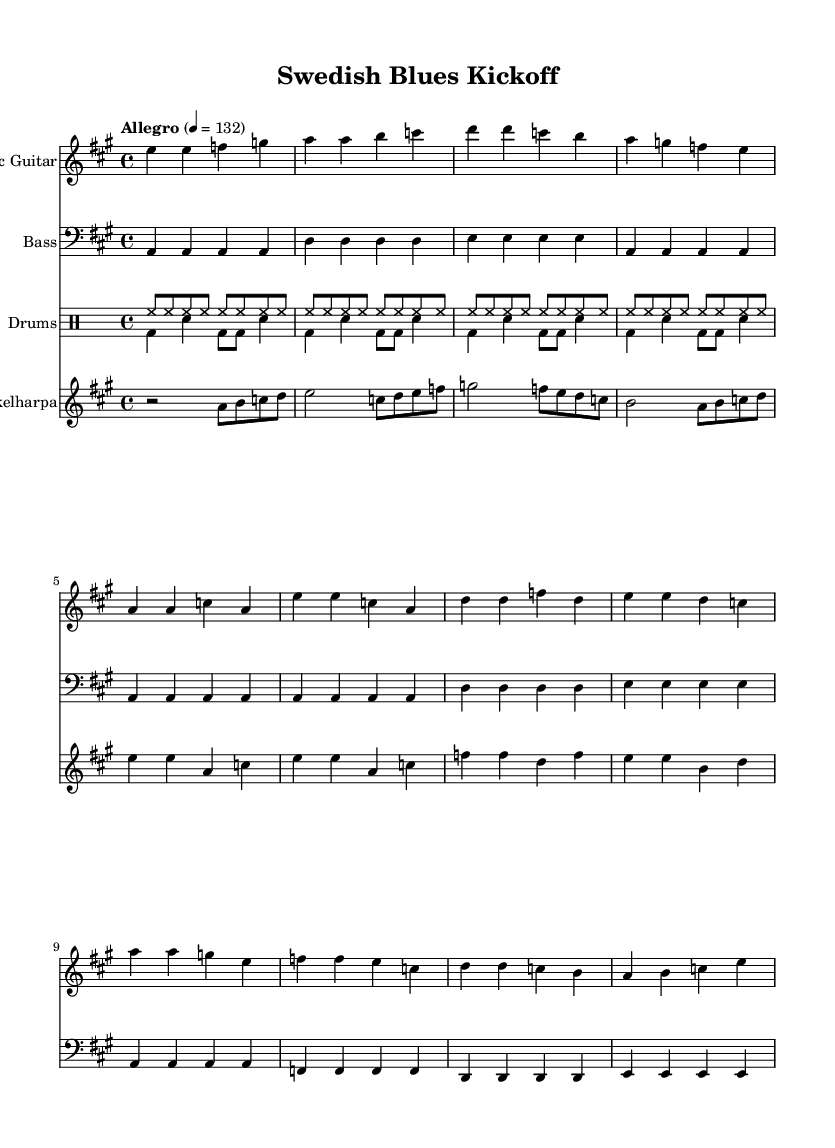What is the key signature of this music? The key signature is A major, which consists of three sharps (F#, C#, and G#). This can be identified in the beginning of the sheet music, where the key signature is indicated.
Answer: A major What is the time signature of this music? The time signature is 4/4, which means there are four beats in a measure and a quarter note receives one beat. This can be found in the beginning of the sheet music, following the key signature.
Answer: 4/4 What is the tempo marking of this piece? The tempo marking is "Allegro" with a tempo of 132 beats per minute. This can be observed in the tempo indication located at the top of the music, which indicates the speed of the piece.
Answer: Allegro, 132 How many measures are in the intro section? The intro section contains four measures. By counting the measures from the starting point of the electric guitar part, we see it clearly divided into measures. Each group of notes between the vertical lines counts as one measure.
Answer: 4 Which instruments are included in this score? The instruments included are Electric Guitar, Bass, Drums, and Nyckelharpa. Each staff in the score is labeled with the respective instrument's name, allowing easy identification of all parts.
Answer: Electric Guitar, Bass, Drums, Nyckelharpa What kind of rhythmic pattern is used in the drum section? The drum section employs a basic blues shuffle pattern. This is indicated by the specific sequences of bass drum (bd), snare (sn), and hi-hat (hh) that create a rhythmic feel typical of Electric Blues music.
Answer: Basic blues shuffle What unique element does the Nyckelharpa add to the music? The Nyckelharpa adds a counterpoint to the main guitar riff. This can be seen as it plays a melodic line that complements the electric guitar throughout the piece, enhancing the Swedish folk influence within the Electric Blues style.
Answer: Counterpoint 